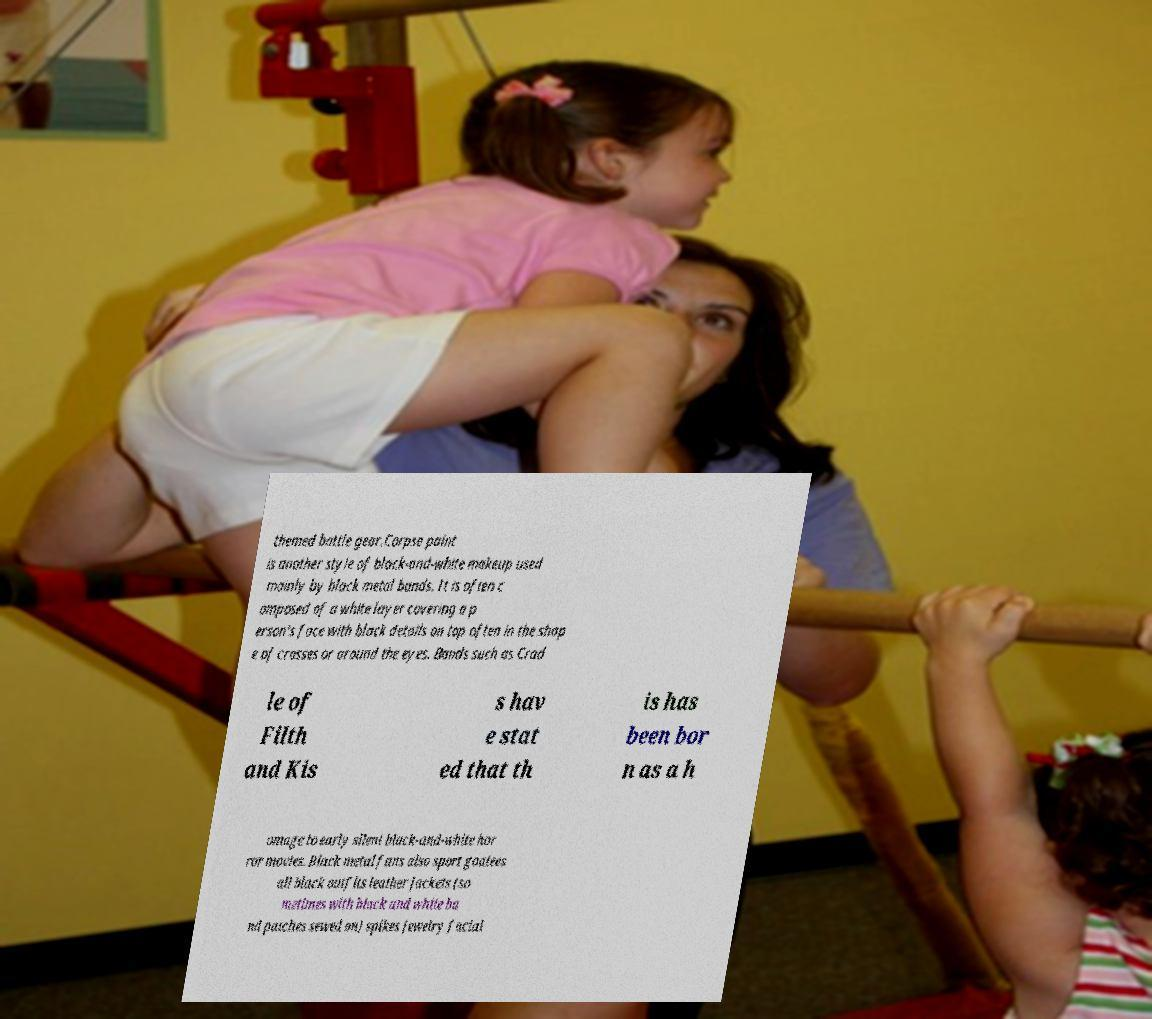Can you read and provide the text displayed in the image?This photo seems to have some interesting text. Can you extract and type it out for me? themed battle gear.Corpse paint is another style of black-and-white makeup used mainly by black metal bands. It is often c omposed of a white layer covering a p erson's face with black details on top often in the shap e of crosses or around the eyes. Bands such as Crad le of Filth and Kis s hav e stat ed that th is has been bor n as a h omage to early silent black-and-white hor ror movies. Black metal fans also sport goatees all black outfits leather jackets (so metimes with black and white ba nd patches sewed on) spikes jewelry facial 